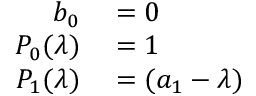Convert formula to latex. <formula><loc_0><loc_0><loc_500><loc_500>\begin{array} { r l } { b _ { 0 } } & = 0 } \\ { P _ { 0 } ( \lambda ) } & = 1 } \\ { P _ { 1 } ( \lambda ) } & = ( a _ { 1 } - \lambda ) } \end{array}</formula> 